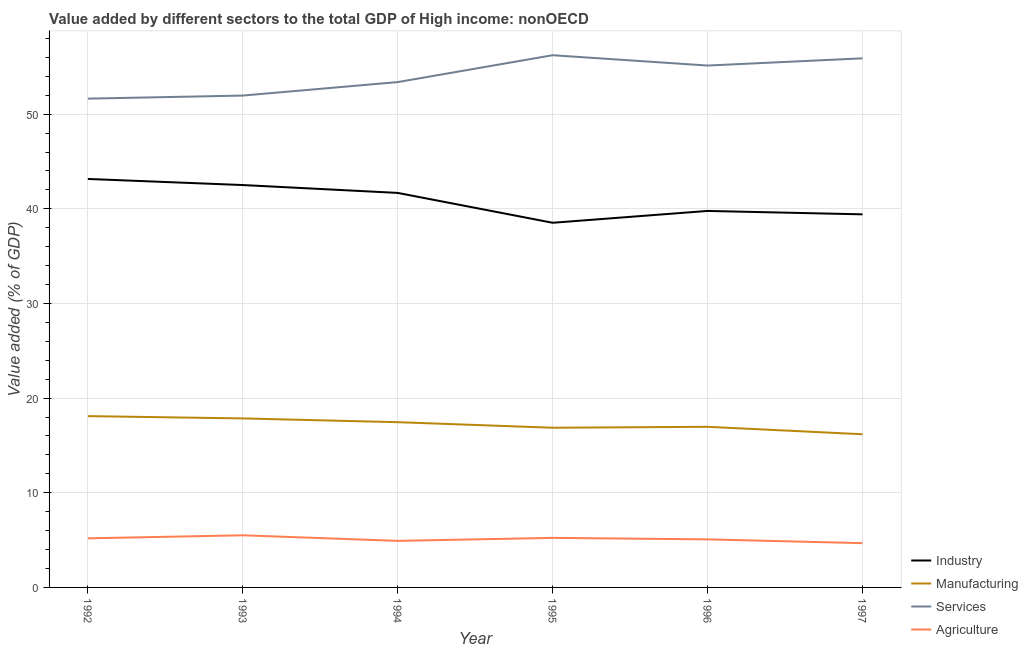How many different coloured lines are there?
Offer a terse response. 4. Does the line corresponding to value added by industrial sector intersect with the line corresponding to value added by manufacturing sector?
Your response must be concise. No. What is the value added by agricultural sector in 1997?
Give a very brief answer. 4.68. Across all years, what is the maximum value added by manufacturing sector?
Make the answer very short. 18.1. Across all years, what is the minimum value added by manufacturing sector?
Offer a very short reply. 16.19. What is the total value added by services sector in the graph?
Your response must be concise. 324.28. What is the difference between the value added by services sector in 1994 and that in 1997?
Provide a short and direct response. -2.51. What is the difference between the value added by manufacturing sector in 1997 and the value added by services sector in 1996?
Your answer should be compact. -38.95. What is the average value added by services sector per year?
Your response must be concise. 54.05. In the year 1994, what is the difference between the value added by industrial sector and value added by manufacturing sector?
Ensure brevity in your answer.  24.23. What is the ratio of the value added by manufacturing sector in 1996 to that in 1997?
Provide a succinct answer. 1.05. Is the value added by agricultural sector in 1993 less than that in 1997?
Ensure brevity in your answer.  No. What is the difference between the highest and the second highest value added by agricultural sector?
Offer a terse response. 0.27. What is the difference between the highest and the lowest value added by manufacturing sector?
Give a very brief answer. 1.91. Does the value added by manufacturing sector monotonically increase over the years?
Offer a terse response. No. Is the value added by agricultural sector strictly less than the value added by industrial sector over the years?
Keep it short and to the point. Yes. How many lines are there?
Keep it short and to the point. 4. How many years are there in the graph?
Your response must be concise. 6. Are the values on the major ticks of Y-axis written in scientific E-notation?
Your answer should be very brief. No. Does the graph contain any zero values?
Ensure brevity in your answer.  No. Does the graph contain grids?
Offer a terse response. Yes. Where does the legend appear in the graph?
Make the answer very short. Bottom right. How many legend labels are there?
Your answer should be very brief. 4. How are the legend labels stacked?
Provide a succinct answer. Vertical. What is the title of the graph?
Keep it short and to the point. Value added by different sectors to the total GDP of High income: nonOECD. Does "Greece" appear as one of the legend labels in the graph?
Make the answer very short. No. What is the label or title of the X-axis?
Your answer should be compact. Year. What is the label or title of the Y-axis?
Offer a very short reply. Value added (% of GDP). What is the Value added (% of GDP) in Industry in 1992?
Provide a short and direct response. 43.16. What is the Value added (% of GDP) in Manufacturing in 1992?
Ensure brevity in your answer.  18.1. What is the Value added (% of GDP) in Services in 1992?
Ensure brevity in your answer.  51.64. What is the Value added (% of GDP) of Agriculture in 1992?
Ensure brevity in your answer.  5.19. What is the Value added (% of GDP) of Industry in 1993?
Your answer should be very brief. 42.51. What is the Value added (% of GDP) of Manufacturing in 1993?
Ensure brevity in your answer.  17.86. What is the Value added (% of GDP) of Services in 1993?
Your response must be concise. 51.97. What is the Value added (% of GDP) of Agriculture in 1993?
Offer a terse response. 5.51. What is the Value added (% of GDP) in Industry in 1994?
Make the answer very short. 41.68. What is the Value added (% of GDP) in Manufacturing in 1994?
Your response must be concise. 17.46. What is the Value added (% of GDP) of Services in 1994?
Provide a short and direct response. 53.39. What is the Value added (% of GDP) of Agriculture in 1994?
Keep it short and to the point. 4.92. What is the Value added (% of GDP) in Industry in 1995?
Keep it short and to the point. 38.53. What is the Value added (% of GDP) of Manufacturing in 1995?
Keep it short and to the point. 16.87. What is the Value added (% of GDP) of Services in 1995?
Offer a terse response. 56.23. What is the Value added (% of GDP) in Agriculture in 1995?
Your response must be concise. 5.23. What is the Value added (% of GDP) in Industry in 1996?
Give a very brief answer. 39.78. What is the Value added (% of GDP) of Manufacturing in 1996?
Your answer should be compact. 16.97. What is the Value added (% of GDP) in Services in 1996?
Make the answer very short. 55.14. What is the Value added (% of GDP) of Agriculture in 1996?
Your response must be concise. 5.08. What is the Value added (% of GDP) of Industry in 1997?
Keep it short and to the point. 39.42. What is the Value added (% of GDP) in Manufacturing in 1997?
Provide a short and direct response. 16.19. What is the Value added (% of GDP) of Services in 1997?
Offer a very short reply. 55.9. What is the Value added (% of GDP) of Agriculture in 1997?
Provide a short and direct response. 4.68. Across all years, what is the maximum Value added (% of GDP) in Industry?
Offer a very short reply. 43.16. Across all years, what is the maximum Value added (% of GDP) of Manufacturing?
Make the answer very short. 18.1. Across all years, what is the maximum Value added (% of GDP) of Services?
Your response must be concise. 56.23. Across all years, what is the maximum Value added (% of GDP) in Agriculture?
Ensure brevity in your answer.  5.51. Across all years, what is the minimum Value added (% of GDP) of Industry?
Give a very brief answer. 38.53. Across all years, what is the minimum Value added (% of GDP) in Manufacturing?
Keep it short and to the point. 16.19. Across all years, what is the minimum Value added (% of GDP) of Services?
Your answer should be compact. 51.64. Across all years, what is the minimum Value added (% of GDP) in Agriculture?
Your response must be concise. 4.68. What is the total Value added (% of GDP) in Industry in the graph?
Keep it short and to the point. 245.08. What is the total Value added (% of GDP) in Manufacturing in the graph?
Make the answer very short. 103.44. What is the total Value added (% of GDP) of Services in the graph?
Your response must be concise. 324.28. What is the total Value added (% of GDP) in Agriculture in the graph?
Ensure brevity in your answer.  30.61. What is the difference between the Value added (% of GDP) of Industry in 1992 and that in 1993?
Provide a succinct answer. 0.64. What is the difference between the Value added (% of GDP) of Manufacturing in 1992 and that in 1993?
Ensure brevity in your answer.  0.24. What is the difference between the Value added (% of GDP) in Services in 1992 and that in 1993?
Provide a succinct answer. -0.32. What is the difference between the Value added (% of GDP) in Agriculture in 1992 and that in 1993?
Your answer should be very brief. -0.32. What is the difference between the Value added (% of GDP) of Industry in 1992 and that in 1994?
Ensure brevity in your answer.  1.47. What is the difference between the Value added (% of GDP) in Manufacturing in 1992 and that in 1994?
Give a very brief answer. 0.64. What is the difference between the Value added (% of GDP) in Services in 1992 and that in 1994?
Make the answer very short. -1.75. What is the difference between the Value added (% of GDP) in Agriculture in 1992 and that in 1994?
Offer a terse response. 0.27. What is the difference between the Value added (% of GDP) of Industry in 1992 and that in 1995?
Give a very brief answer. 4.63. What is the difference between the Value added (% of GDP) of Manufacturing in 1992 and that in 1995?
Provide a succinct answer. 1.23. What is the difference between the Value added (% of GDP) of Services in 1992 and that in 1995?
Your answer should be very brief. -4.59. What is the difference between the Value added (% of GDP) in Agriculture in 1992 and that in 1995?
Your answer should be compact. -0.05. What is the difference between the Value added (% of GDP) in Industry in 1992 and that in 1996?
Keep it short and to the point. 3.38. What is the difference between the Value added (% of GDP) of Manufacturing in 1992 and that in 1996?
Offer a very short reply. 1.13. What is the difference between the Value added (% of GDP) of Services in 1992 and that in 1996?
Provide a short and direct response. -3.5. What is the difference between the Value added (% of GDP) of Agriculture in 1992 and that in 1996?
Provide a short and direct response. 0.11. What is the difference between the Value added (% of GDP) of Industry in 1992 and that in 1997?
Offer a terse response. 3.74. What is the difference between the Value added (% of GDP) in Manufacturing in 1992 and that in 1997?
Give a very brief answer. 1.91. What is the difference between the Value added (% of GDP) in Services in 1992 and that in 1997?
Your answer should be compact. -4.26. What is the difference between the Value added (% of GDP) in Agriculture in 1992 and that in 1997?
Make the answer very short. 0.51. What is the difference between the Value added (% of GDP) of Industry in 1993 and that in 1994?
Provide a short and direct response. 0.83. What is the difference between the Value added (% of GDP) of Manufacturing in 1993 and that in 1994?
Give a very brief answer. 0.4. What is the difference between the Value added (% of GDP) in Services in 1993 and that in 1994?
Your response must be concise. -1.42. What is the difference between the Value added (% of GDP) of Agriculture in 1993 and that in 1994?
Your response must be concise. 0.59. What is the difference between the Value added (% of GDP) of Industry in 1993 and that in 1995?
Keep it short and to the point. 3.99. What is the difference between the Value added (% of GDP) in Manufacturing in 1993 and that in 1995?
Your answer should be very brief. 0.98. What is the difference between the Value added (% of GDP) of Services in 1993 and that in 1995?
Your answer should be compact. -4.26. What is the difference between the Value added (% of GDP) of Agriculture in 1993 and that in 1995?
Your answer should be very brief. 0.27. What is the difference between the Value added (% of GDP) in Industry in 1993 and that in 1996?
Your answer should be very brief. 2.73. What is the difference between the Value added (% of GDP) of Manufacturing in 1993 and that in 1996?
Keep it short and to the point. 0.89. What is the difference between the Value added (% of GDP) of Services in 1993 and that in 1996?
Offer a very short reply. -3.17. What is the difference between the Value added (% of GDP) of Agriculture in 1993 and that in 1996?
Keep it short and to the point. 0.43. What is the difference between the Value added (% of GDP) in Industry in 1993 and that in 1997?
Your response must be concise. 3.1. What is the difference between the Value added (% of GDP) in Manufacturing in 1993 and that in 1997?
Make the answer very short. 1.67. What is the difference between the Value added (% of GDP) in Services in 1993 and that in 1997?
Offer a very short reply. -3.93. What is the difference between the Value added (% of GDP) in Agriculture in 1993 and that in 1997?
Your response must be concise. 0.83. What is the difference between the Value added (% of GDP) in Industry in 1994 and that in 1995?
Offer a terse response. 3.16. What is the difference between the Value added (% of GDP) in Manufacturing in 1994 and that in 1995?
Offer a terse response. 0.59. What is the difference between the Value added (% of GDP) of Services in 1994 and that in 1995?
Your answer should be compact. -2.84. What is the difference between the Value added (% of GDP) in Agriculture in 1994 and that in 1995?
Keep it short and to the point. -0.32. What is the difference between the Value added (% of GDP) in Industry in 1994 and that in 1996?
Keep it short and to the point. 1.9. What is the difference between the Value added (% of GDP) in Manufacturing in 1994 and that in 1996?
Your answer should be compact. 0.49. What is the difference between the Value added (% of GDP) in Services in 1994 and that in 1996?
Ensure brevity in your answer.  -1.75. What is the difference between the Value added (% of GDP) of Agriculture in 1994 and that in 1996?
Ensure brevity in your answer.  -0.16. What is the difference between the Value added (% of GDP) of Industry in 1994 and that in 1997?
Offer a terse response. 2.27. What is the difference between the Value added (% of GDP) of Manufacturing in 1994 and that in 1997?
Keep it short and to the point. 1.27. What is the difference between the Value added (% of GDP) of Services in 1994 and that in 1997?
Offer a terse response. -2.51. What is the difference between the Value added (% of GDP) in Agriculture in 1994 and that in 1997?
Offer a terse response. 0.24. What is the difference between the Value added (% of GDP) of Industry in 1995 and that in 1996?
Offer a terse response. -1.25. What is the difference between the Value added (% of GDP) of Manufacturing in 1995 and that in 1996?
Provide a short and direct response. -0.1. What is the difference between the Value added (% of GDP) in Services in 1995 and that in 1996?
Your answer should be compact. 1.09. What is the difference between the Value added (% of GDP) of Agriculture in 1995 and that in 1996?
Offer a terse response. 0.16. What is the difference between the Value added (% of GDP) in Industry in 1995 and that in 1997?
Make the answer very short. -0.89. What is the difference between the Value added (% of GDP) of Manufacturing in 1995 and that in 1997?
Provide a succinct answer. 0.69. What is the difference between the Value added (% of GDP) of Services in 1995 and that in 1997?
Offer a very short reply. 0.33. What is the difference between the Value added (% of GDP) of Agriculture in 1995 and that in 1997?
Your answer should be compact. 0.56. What is the difference between the Value added (% of GDP) in Industry in 1996 and that in 1997?
Your response must be concise. 0.36. What is the difference between the Value added (% of GDP) of Manufacturing in 1996 and that in 1997?
Offer a terse response. 0.78. What is the difference between the Value added (% of GDP) in Services in 1996 and that in 1997?
Your response must be concise. -0.76. What is the difference between the Value added (% of GDP) of Agriculture in 1996 and that in 1997?
Make the answer very short. 0.4. What is the difference between the Value added (% of GDP) in Industry in 1992 and the Value added (% of GDP) in Manufacturing in 1993?
Make the answer very short. 25.3. What is the difference between the Value added (% of GDP) of Industry in 1992 and the Value added (% of GDP) of Services in 1993?
Your answer should be very brief. -8.81. What is the difference between the Value added (% of GDP) of Industry in 1992 and the Value added (% of GDP) of Agriculture in 1993?
Ensure brevity in your answer.  37.65. What is the difference between the Value added (% of GDP) of Manufacturing in 1992 and the Value added (% of GDP) of Services in 1993?
Keep it short and to the point. -33.87. What is the difference between the Value added (% of GDP) of Manufacturing in 1992 and the Value added (% of GDP) of Agriculture in 1993?
Your answer should be very brief. 12.59. What is the difference between the Value added (% of GDP) of Services in 1992 and the Value added (% of GDP) of Agriculture in 1993?
Your answer should be very brief. 46.14. What is the difference between the Value added (% of GDP) of Industry in 1992 and the Value added (% of GDP) of Manufacturing in 1994?
Make the answer very short. 25.7. What is the difference between the Value added (% of GDP) of Industry in 1992 and the Value added (% of GDP) of Services in 1994?
Keep it short and to the point. -10.23. What is the difference between the Value added (% of GDP) of Industry in 1992 and the Value added (% of GDP) of Agriculture in 1994?
Provide a short and direct response. 38.24. What is the difference between the Value added (% of GDP) of Manufacturing in 1992 and the Value added (% of GDP) of Services in 1994?
Your answer should be compact. -35.29. What is the difference between the Value added (% of GDP) in Manufacturing in 1992 and the Value added (% of GDP) in Agriculture in 1994?
Your answer should be very brief. 13.18. What is the difference between the Value added (% of GDP) of Services in 1992 and the Value added (% of GDP) of Agriculture in 1994?
Your answer should be compact. 46.72. What is the difference between the Value added (% of GDP) of Industry in 1992 and the Value added (% of GDP) of Manufacturing in 1995?
Your answer should be very brief. 26.29. What is the difference between the Value added (% of GDP) of Industry in 1992 and the Value added (% of GDP) of Services in 1995?
Keep it short and to the point. -13.07. What is the difference between the Value added (% of GDP) of Industry in 1992 and the Value added (% of GDP) of Agriculture in 1995?
Your response must be concise. 37.92. What is the difference between the Value added (% of GDP) in Manufacturing in 1992 and the Value added (% of GDP) in Services in 1995?
Keep it short and to the point. -38.13. What is the difference between the Value added (% of GDP) of Manufacturing in 1992 and the Value added (% of GDP) of Agriculture in 1995?
Provide a short and direct response. 12.87. What is the difference between the Value added (% of GDP) of Services in 1992 and the Value added (% of GDP) of Agriculture in 1995?
Your answer should be very brief. 46.41. What is the difference between the Value added (% of GDP) of Industry in 1992 and the Value added (% of GDP) of Manufacturing in 1996?
Provide a succinct answer. 26.19. What is the difference between the Value added (% of GDP) of Industry in 1992 and the Value added (% of GDP) of Services in 1996?
Ensure brevity in your answer.  -11.98. What is the difference between the Value added (% of GDP) in Industry in 1992 and the Value added (% of GDP) in Agriculture in 1996?
Provide a short and direct response. 38.08. What is the difference between the Value added (% of GDP) in Manufacturing in 1992 and the Value added (% of GDP) in Services in 1996?
Your answer should be very brief. -37.04. What is the difference between the Value added (% of GDP) of Manufacturing in 1992 and the Value added (% of GDP) of Agriculture in 1996?
Provide a succinct answer. 13.02. What is the difference between the Value added (% of GDP) in Services in 1992 and the Value added (% of GDP) in Agriculture in 1996?
Make the answer very short. 46.57. What is the difference between the Value added (% of GDP) in Industry in 1992 and the Value added (% of GDP) in Manufacturing in 1997?
Offer a terse response. 26.97. What is the difference between the Value added (% of GDP) in Industry in 1992 and the Value added (% of GDP) in Services in 1997?
Your answer should be very brief. -12.74. What is the difference between the Value added (% of GDP) of Industry in 1992 and the Value added (% of GDP) of Agriculture in 1997?
Provide a short and direct response. 38.48. What is the difference between the Value added (% of GDP) of Manufacturing in 1992 and the Value added (% of GDP) of Services in 1997?
Your answer should be compact. -37.8. What is the difference between the Value added (% of GDP) of Manufacturing in 1992 and the Value added (% of GDP) of Agriculture in 1997?
Offer a terse response. 13.42. What is the difference between the Value added (% of GDP) in Services in 1992 and the Value added (% of GDP) in Agriculture in 1997?
Your response must be concise. 46.97. What is the difference between the Value added (% of GDP) of Industry in 1993 and the Value added (% of GDP) of Manufacturing in 1994?
Ensure brevity in your answer.  25.06. What is the difference between the Value added (% of GDP) of Industry in 1993 and the Value added (% of GDP) of Services in 1994?
Give a very brief answer. -10.88. What is the difference between the Value added (% of GDP) of Industry in 1993 and the Value added (% of GDP) of Agriculture in 1994?
Ensure brevity in your answer.  37.59. What is the difference between the Value added (% of GDP) in Manufacturing in 1993 and the Value added (% of GDP) in Services in 1994?
Your answer should be very brief. -35.54. What is the difference between the Value added (% of GDP) in Manufacturing in 1993 and the Value added (% of GDP) in Agriculture in 1994?
Provide a succinct answer. 12.94. What is the difference between the Value added (% of GDP) in Services in 1993 and the Value added (% of GDP) in Agriculture in 1994?
Your answer should be compact. 47.05. What is the difference between the Value added (% of GDP) of Industry in 1993 and the Value added (% of GDP) of Manufacturing in 1995?
Your response must be concise. 25.64. What is the difference between the Value added (% of GDP) of Industry in 1993 and the Value added (% of GDP) of Services in 1995?
Your answer should be compact. -13.72. What is the difference between the Value added (% of GDP) in Industry in 1993 and the Value added (% of GDP) in Agriculture in 1995?
Ensure brevity in your answer.  37.28. What is the difference between the Value added (% of GDP) of Manufacturing in 1993 and the Value added (% of GDP) of Services in 1995?
Make the answer very short. -38.37. What is the difference between the Value added (% of GDP) in Manufacturing in 1993 and the Value added (% of GDP) in Agriculture in 1995?
Make the answer very short. 12.62. What is the difference between the Value added (% of GDP) of Services in 1993 and the Value added (% of GDP) of Agriculture in 1995?
Your answer should be very brief. 46.73. What is the difference between the Value added (% of GDP) in Industry in 1993 and the Value added (% of GDP) in Manufacturing in 1996?
Offer a terse response. 25.54. What is the difference between the Value added (% of GDP) of Industry in 1993 and the Value added (% of GDP) of Services in 1996?
Your response must be concise. -12.63. What is the difference between the Value added (% of GDP) in Industry in 1993 and the Value added (% of GDP) in Agriculture in 1996?
Make the answer very short. 37.44. What is the difference between the Value added (% of GDP) in Manufacturing in 1993 and the Value added (% of GDP) in Services in 1996?
Provide a short and direct response. -37.28. What is the difference between the Value added (% of GDP) in Manufacturing in 1993 and the Value added (% of GDP) in Agriculture in 1996?
Offer a very short reply. 12.78. What is the difference between the Value added (% of GDP) in Services in 1993 and the Value added (% of GDP) in Agriculture in 1996?
Offer a terse response. 46.89. What is the difference between the Value added (% of GDP) of Industry in 1993 and the Value added (% of GDP) of Manufacturing in 1997?
Your response must be concise. 26.33. What is the difference between the Value added (% of GDP) of Industry in 1993 and the Value added (% of GDP) of Services in 1997?
Your response must be concise. -13.39. What is the difference between the Value added (% of GDP) in Industry in 1993 and the Value added (% of GDP) in Agriculture in 1997?
Make the answer very short. 37.84. What is the difference between the Value added (% of GDP) of Manufacturing in 1993 and the Value added (% of GDP) of Services in 1997?
Your response must be concise. -38.05. What is the difference between the Value added (% of GDP) in Manufacturing in 1993 and the Value added (% of GDP) in Agriculture in 1997?
Offer a very short reply. 13.18. What is the difference between the Value added (% of GDP) of Services in 1993 and the Value added (% of GDP) of Agriculture in 1997?
Provide a succinct answer. 47.29. What is the difference between the Value added (% of GDP) in Industry in 1994 and the Value added (% of GDP) in Manufacturing in 1995?
Provide a short and direct response. 24.81. What is the difference between the Value added (% of GDP) in Industry in 1994 and the Value added (% of GDP) in Services in 1995?
Provide a short and direct response. -14.55. What is the difference between the Value added (% of GDP) of Industry in 1994 and the Value added (% of GDP) of Agriculture in 1995?
Offer a very short reply. 36.45. What is the difference between the Value added (% of GDP) in Manufacturing in 1994 and the Value added (% of GDP) in Services in 1995?
Offer a terse response. -38.77. What is the difference between the Value added (% of GDP) in Manufacturing in 1994 and the Value added (% of GDP) in Agriculture in 1995?
Your answer should be compact. 12.22. What is the difference between the Value added (% of GDP) in Services in 1994 and the Value added (% of GDP) in Agriculture in 1995?
Your response must be concise. 48.16. What is the difference between the Value added (% of GDP) in Industry in 1994 and the Value added (% of GDP) in Manufacturing in 1996?
Ensure brevity in your answer.  24.71. What is the difference between the Value added (% of GDP) of Industry in 1994 and the Value added (% of GDP) of Services in 1996?
Make the answer very short. -13.46. What is the difference between the Value added (% of GDP) of Industry in 1994 and the Value added (% of GDP) of Agriculture in 1996?
Make the answer very short. 36.61. What is the difference between the Value added (% of GDP) in Manufacturing in 1994 and the Value added (% of GDP) in Services in 1996?
Provide a short and direct response. -37.68. What is the difference between the Value added (% of GDP) in Manufacturing in 1994 and the Value added (% of GDP) in Agriculture in 1996?
Make the answer very short. 12.38. What is the difference between the Value added (% of GDP) of Services in 1994 and the Value added (% of GDP) of Agriculture in 1996?
Offer a terse response. 48.31. What is the difference between the Value added (% of GDP) in Industry in 1994 and the Value added (% of GDP) in Manufacturing in 1997?
Offer a terse response. 25.5. What is the difference between the Value added (% of GDP) of Industry in 1994 and the Value added (% of GDP) of Services in 1997?
Offer a terse response. -14.22. What is the difference between the Value added (% of GDP) of Industry in 1994 and the Value added (% of GDP) of Agriculture in 1997?
Offer a very short reply. 37.01. What is the difference between the Value added (% of GDP) in Manufacturing in 1994 and the Value added (% of GDP) in Services in 1997?
Your answer should be compact. -38.44. What is the difference between the Value added (% of GDP) in Manufacturing in 1994 and the Value added (% of GDP) in Agriculture in 1997?
Offer a very short reply. 12.78. What is the difference between the Value added (% of GDP) of Services in 1994 and the Value added (% of GDP) of Agriculture in 1997?
Offer a terse response. 48.72. What is the difference between the Value added (% of GDP) in Industry in 1995 and the Value added (% of GDP) in Manufacturing in 1996?
Provide a succinct answer. 21.56. What is the difference between the Value added (% of GDP) in Industry in 1995 and the Value added (% of GDP) in Services in 1996?
Ensure brevity in your answer.  -16.61. What is the difference between the Value added (% of GDP) of Industry in 1995 and the Value added (% of GDP) of Agriculture in 1996?
Provide a short and direct response. 33.45. What is the difference between the Value added (% of GDP) of Manufacturing in 1995 and the Value added (% of GDP) of Services in 1996?
Offer a terse response. -38.27. What is the difference between the Value added (% of GDP) of Manufacturing in 1995 and the Value added (% of GDP) of Agriculture in 1996?
Your answer should be very brief. 11.79. What is the difference between the Value added (% of GDP) in Services in 1995 and the Value added (% of GDP) in Agriculture in 1996?
Offer a very short reply. 51.15. What is the difference between the Value added (% of GDP) of Industry in 1995 and the Value added (% of GDP) of Manufacturing in 1997?
Give a very brief answer. 22.34. What is the difference between the Value added (% of GDP) in Industry in 1995 and the Value added (% of GDP) in Services in 1997?
Give a very brief answer. -17.37. What is the difference between the Value added (% of GDP) in Industry in 1995 and the Value added (% of GDP) in Agriculture in 1997?
Give a very brief answer. 33.85. What is the difference between the Value added (% of GDP) of Manufacturing in 1995 and the Value added (% of GDP) of Services in 1997?
Offer a terse response. -39.03. What is the difference between the Value added (% of GDP) in Manufacturing in 1995 and the Value added (% of GDP) in Agriculture in 1997?
Provide a succinct answer. 12.19. What is the difference between the Value added (% of GDP) of Services in 1995 and the Value added (% of GDP) of Agriculture in 1997?
Your answer should be compact. 51.55. What is the difference between the Value added (% of GDP) in Industry in 1996 and the Value added (% of GDP) in Manufacturing in 1997?
Provide a short and direct response. 23.59. What is the difference between the Value added (% of GDP) in Industry in 1996 and the Value added (% of GDP) in Services in 1997?
Provide a succinct answer. -16.12. What is the difference between the Value added (% of GDP) in Industry in 1996 and the Value added (% of GDP) in Agriculture in 1997?
Keep it short and to the point. 35.1. What is the difference between the Value added (% of GDP) in Manufacturing in 1996 and the Value added (% of GDP) in Services in 1997?
Your response must be concise. -38.93. What is the difference between the Value added (% of GDP) in Manufacturing in 1996 and the Value added (% of GDP) in Agriculture in 1997?
Keep it short and to the point. 12.29. What is the difference between the Value added (% of GDP) of Services in 1996 and the Value added (% of GDP) of Agriculture in 1997?
Your response must be concise. 50.46. What is the average Value added (% of GDP) of Industry per year?
Provide a succinct answer. 40.85. What is the average Value added (% of GDP) of Manufacturing per year?
Make the answer very short. 17.24. What is the average Value added (% of GDP) in Services per year?
Make the answer very short. 54.05. What is the average Value added (% of GDP) in Agriculture per year?
Give a very brief answer. 5.1. In the year 1992, what is the difference between the Value added (% of GDP) of Industry and Value added (% of GDP) of Manufacturing?
Your response must be concise. 25.06. In the year 1992, what is the difference between the Value added (% of GDP) of Industry and Value added (% of GDP) of Services?
Provide a short and direct response. -8.49. In the year 1992, what is the difference between the Value added (% of GDP) in Industry and Value added (% of GDP) in Agriculture?
Ensure brevity in your answer.  37.97. In the year 1992, what is the difference between the Value added (% of GDP) in Manufacturing and Value added (% of GDP) in Services?
Give a very brief answer. -33.54. In the year 1992, what is the difference between the Value added (% of GDP) in Manufacturing and Value added (% of GDP) in Agriculture?
Provide a succinct answer. 12.91. In the year 1992, what is the difference between the Value added (% of GDP) in Services and Value added (% of GDP) in Agriculture?
Your answer should be compact. 46.46. In the year 1993, what is the difference between the Value added (% of GDP) of Industry and Value added (% of GDP) of Manufacturing?
Provide a short and direct response. 24.66. In the year 1993, what is the difference between the Value added (% of GDP) in Industry and Value added (% of GDP) in Services?
Provide a short and direct response. -9.45. In the year 1993, what is the difference between the Value added (% of GDP) of Industry and Value added (% of GDP) of Agriculture?
Offer a terse response. 37.01. In the year 1993, what is the difference between the Value added (% of GDP) in Manufacturing and Value added (% of GDP) in Services?
Offer a very short reply. -34.11. In the year 1993, what is the difference between the Value added (% of GDP) in Manufacturing and Value added (% of GDP) in Agriculture?
Provide a succinct answer. 12.35. In the year 1993, what is the difference between the Value added (% of GDP) of Services and Value added (% of GDP) of Agriculture?
Your response must be concise. 46.46. In the year 1994, what is the difference between the Value added (% of GDP) in Industry and Value added (% of GDP) in Manufacturing?
Offer a very short reply. 24.23. In the year 1994, what is the difference between the Value added (% of GDP) of Industry and Value added (% of GDP) of Services?
Offer a terse response. -11.71. In the year 1994, what is the difference between the Value added (% of GDP) of Industry and Value added (% of GDP) of Agriculture?
Provide a succinct answer. 36.76. In the year 1994, what is the difference between the Value added (% of GDP) of Manufacturing and Value added (% of GDP) of Services?
Provide a short and direct response. -35.93. In the year 1994, what is the difference between the Value added (% of GDP) of Manufacturing and Value added (% of GDP) of Agriculture?
Make the answer very short. 12.54. In the year 1994, what is the difference between the Value added (% of GDP) in Services and Value added (% of GDP) in Agriculture?
Keep it short and to the point. 48.47. In the year 1995, what is the difference between the Value added (% of GDP) in Industry and Value added (% of GDP) in Manufacturing?
Your answer should be very brief. 21.66. In the year 1995, what is the difference between the Value added (% of GDP) in Industry and Value added (% of GDP) in Services?
Provide a short and direct response. -17.7. In the year 1995, what is the difference between the Value added (% of GDP) of Industry and Value added (% of GDP) of Agriculture?
Offer a very short reply. 33.29. In the year 1995, what is the difference between the Value added (% of GDP) of Manufacturing and Value added (% of GDP) of Services?
Give a very brief answer. -39.36. In the year 1995, what is the difference between the Value added (% of GDP) of Manufacturing and Value added (% of GDP) of Agriculture?
Your response must be concise. 11.64. In the year 1995, what is the difference between the Value added (% of GDP) of Services and Value added (% of GDP) of Agriculture?
Your response must be concise. 51. In the year 1996, what is the difference between the Value added (% of GDP) of Industry and Value added (% of GDP) of Manufacturing?
Keep it short and to the point. 22.81. In the year 1996, what is the difference between the Value added (% of GDP) of Industry and Value added (% of GDP) of Services?
Make the answer very short. -15.36. In the year 1996, what is the difference between the Value added (% of GDP) of Industry and Value added (% of GDP) of Agriculture?
Provide a succinct answer. 34.7. In the year 1996, what is the difference between the Value added (% of GDP) in Manufacturing and Value added (% of GDP) in Services?
Offer a very short reply. -38.17. In the year 1996, what is the difference between the Value added (% of GDP) of Manufacturing and Value added (% of GDP) of Agriculture?
Make the answer very short. 11.89. In the year 1996, what is the difference between the Value added (% of GDP) in Services and Value added (% of GDP) in Agriculture?
Your answer should be compact. 50.06. In the year 1997, what is the difference between the Value added (% of GDP) of Industry and Value added (% of GDP) of Manufacturing?
Ensure brevity in your answer.  23.23. In the year 1997, what is the difference between the Value added (% of GDP) of Industry and Value added (% of GDP) of Services?
Ensure brevity in your answer.  -16.48. In the year 1997, what is the difference between the Value added (% of GDP) of Industry and Value added (% of GDP) of Agriculture?
Give a very brief answer. 34.74. In the year 1997, what is the difference between the Value added (% of GDP) of Manufacturing and Value added (% of GDP) of Services?
Keep it short and to the point. -39.72. In the year 1997, what is the difference between the Value added (% of GDP) of Manufacturing and Value added (% of GDP) of Agriculture?
Make the answer very short. 11.51. In the year 1997, what is the difference between the Value added (% of GDP) of Services and Value added (% of GDP) of Agriculture?
Provide a short and direct response. 51.23. What is the ratio of the Value added (% of GDP) in Industry in 1992 to that in 1993?
Ensure brevity in your answer.  1.02. What is the ratio of the Value added (% of GDP) in Manufacturing in 1992 to that in 1993?
Your response must be concise. 1.01. What is the ratio of the Value added (% of GDP) of Agriculture in 1992 to that in 1993?
Provide a short and direct response. 0.94. What is the ratio of the Value added (% of GDP) in Industry in 1992 to that in 1994?
Provide a short and direct response. 1.04. What is the ratio of the Value added (% of GDP) in Manufacturing in 1992 to that in 1994?
Offer a terse response. 1.04. What is the ratio of the Value added (% of GDP) of Services in 1992 to that in 1994?
Your response must be concise. 0.97. What is the ratio of the Value added (% of GDP) in Agriculture in 1992 to that in 1994?
Give a very brief answer. 1.05. What is the ratio of the Value added (% of GDP) in Industry in 1992 to that in 1995?
Give a very brief answer. 1.12. What is the ratio of the Value added (% of GDP) in Manufacturing in 1992 to that in 1995?
Your response must be concise. 1.07. What is the ratio of the Value added (% of GDP) in Services in 1992 to that in 1995?
Your response must be concise. 0.92. What is the ratio of the Value added (% of GDP) of Agriculture in 1992 to that in 1995?
Your answer should be compact. 0.99. What is the ratio of the Value added (% of GDP) of Industry in 1992 to that in 1996?
Provide a short and direct response. 1.08. What is the ratio of the Value added (% of GDP) of Manufacturing in 1992 to that in 1996?
Make the answer very short. 1.07. What is the ratio of the Value added (% of GDP) in Services in 1992 to that in 1996?
Provide a succinct answer. 0.94. What is the ratio of the Value added (% of GDP) in Agriculture in 1992 to that in 1996?
Provide a succinct answer. 1.02. What is the ratio of the Value added (% of GDP) in Industry in 1992 to that in 1997?
Your answer should be compact. 1.09. What is the ratio of the Value added (% of GDP) in Manufacturing in 1992 to that in 1997?
Give a very brief answer. 1.12. What is the ratio of the Value added (% of GDP) of Services in 1992 to that in 1997?
Your response must be concise. 0.92. What is the ratio of the Value added (% of GDP) in Agriculture in 1992 to that in 1997?
Make the answer very short. 1.11. What is the ratio of the Value added (% of GDP) of Industry in 1993 to that in 1994?
Your answer should be compact. 1.02. What is the ratio of the Value added (% of GDP) in Manufacturing in 1993 to that in 1994?
Ensure brevity in your answer.  1.02. What is the ratio of the Value added (% of GDP) in Services in 1993 to that in 1994?
Keep it short and to the point. 0.97. What is the ratio of the Value added (% of GDP) of Agriculture in 1993 to that in 1994?
Ensure brevity in your answer.  1.12. What is the ratio of the Value added (% of GDP) in Industry in 1993 to that in 1995?
Your answer should be compact. 1.1. What is the ratio of the Value added (% of GDP) of Manufacturing in 1993 to that in 1995?
Provide a succinct answer. 1.06. What is the ratio of the Value added (% of GDP) of Services in 1993 to that in 1995?
Provide a succinct answer. 0.92. What is the ratio of the Value added (% of GDP) in Agriculture in 1993 to that in 1995?
Offer a very short reply. 1.05. What is the ratio of the Value added (% of GDP) of Industry in 1993 to that in 1996?
Keep it short and to the point. 1.07. What is the ratio of the Value added (% of GDP) of Manufacturing in 1993 to that in 1996?
Your answer should be compact. 1.05. What is the ratio of the Value added (% of GDP) of Services in 1993 to that in 1996?
Make the answer very short. 0.94. What is the ratio of the Value added (% of GDP) of Agriculture in 1993 to that in 1996?
Make the answer very short. 1.08. What is the ratio of the Value added (% of GDP) of Industry in 1993 to that in 1997?
Your answer should be compact. 1.08. What is the ratio of the Value added (% of GDP) of Manufacturing in 1993 to that in 1997?
Make the answer very short. 1.1. What is the ratio of the Value added (% of GDP) in Services in 1993 to that in 1997?
Give a very brief answer. 0.93. What is the ratio of the Value added (% of GDP) in Agriculture in 1993 to that in 1997?
Offer a terse response. 1.18. What is the ratio of the Value added (% of GDP) of Industry in 1994 to that in 1995?
Provide a short and direct response. 1.08. What is the ratio of the Value added (% of GDP) in Manufacturing in 1994 to that in 1995?
Offer a very short reply. 1.03. What is the ratio of the Value added (% of GDP) in Services in 1994 to that in 1995?
Offer a terse response. 0.95. What is the ratio of the Value added (% of GDP) in Agriculture in 1994 to that in 1995?
Provide a short and direct response. 0.94. What is the ratio of the Value added (% of GDP) of Industry in 1994 to that in 1996?
Ensure brevity in your answer.  1.05. What is the ratio of the Value added (% of GDP) of Manufacturing in 1994 to that in 1996?
Provide a succinct answer. 1.03. What is the ratio of the Value added (% of GDP) in Services in 1994 to that in 1996?
Offer a very short reply. 0.97. What is the ratio of the Value added (% of GDP) of Agriculture in 1994 to that in 1996?
Give a very brief answer. 0.97. What is the ratio of the Value added (% of GDP) of Industry in 1994 to that in 1997?
Your answer should be very brief. 1.06. What is the ratio of the Value added (% of GDP) in Manufacturing in 1994 to that in 1997?
Offer a terse response. 1.08. What is the ratio of the Value added (% of GDP) of Services in 1994 to that in 1997?
Provide a succinct answer. 0.96. What is the ratio of the Value added (% of GDP) in Agriculture in 1994 to that in 1997?
Keep it short and to the point. 1.05. What is the ratio of the Value added (% of GDP) in Industry in 1995 to that in 1996?
Provide a short and direct response. 0.97. What is the ratio of the Value added (% of GDP) of Manufacturing in 1995 to that in 1996?
Give a very brief answer. 0.99. What is the ratio of the Value added (% of GDP) of Services in 1995 to that in 1996?
Provide a short and direct response. 1.02. What is the ratio of the Value added (% of GDP) in Agriculture in 1995 to that in 1996?
Keep it short and to the point. 1.03. What is the ratio of the Value added (% of GDP) in Industry in 1995 to that in 1997?
Give a very brief answer. 0.98. What is the ratio of the Value added (% of GDP) of Manufacturing in 1995 to that in 1997?
Your response must be concise. 1.04. What is the ratio of the Value added (% of GDP) in Services in 1995 to that in 1997?
Provide a succinct answer. 1.01. What is the ratio of the Value added (% of GDP) in Agriculture in 1995 to that in 1997?
Keep it short and to the point. 1.12. What is the ratio of the Value added (% of GDP) in Industry in 1996 to that in 1997?
Give a very brief answer. 1.01. What is the ratio of the Value added (% of GDP) of Manufacturing in 1996 to that in 1997?
Give a very brief answer. 1.05. What is the ratio of the Value added (% of GDP) in Services in 1996 to that in 1997?
Your answer should be very brief. 0.99. What is the ratio of the Value added (% of GDP) in Agriculture in 1996 to that in 1997?
Offer a terse response. 1.09. What is the difference between the highest and the second highest Value added (% of GDP) of Industry?
Ensure brevity in your answer.  0.64. What is the difference between the highest and the second highest Value added (% of GDP) in Manufacturing?
Offer a terse response. 0.24. What is the difference between the highest and the second highest Value added (% of GDP) of Services?
Keep it short and to the point. 0.33. What is the difference between the highest and the second highest Value added (% of GDP) in Agriculture?
Provide a succinct answer. 0.27. What is the difference between the highest and the lowest Value added (% of GDP) of Industry?
Your response must be concise. 4.63. What is the difference between the highest and the lowest Value added (% of GDP) in Manufacturing?
Provide a short and direct response. 1.91. What is the difference between the highest and the lowest Value added (% of GDP) of Services?
Your answer should be very brief. 4.59. What is the difference between the highest and the lowest Value added (% of GDP) of Agriculture?
Make the answer very short. 0.83. 